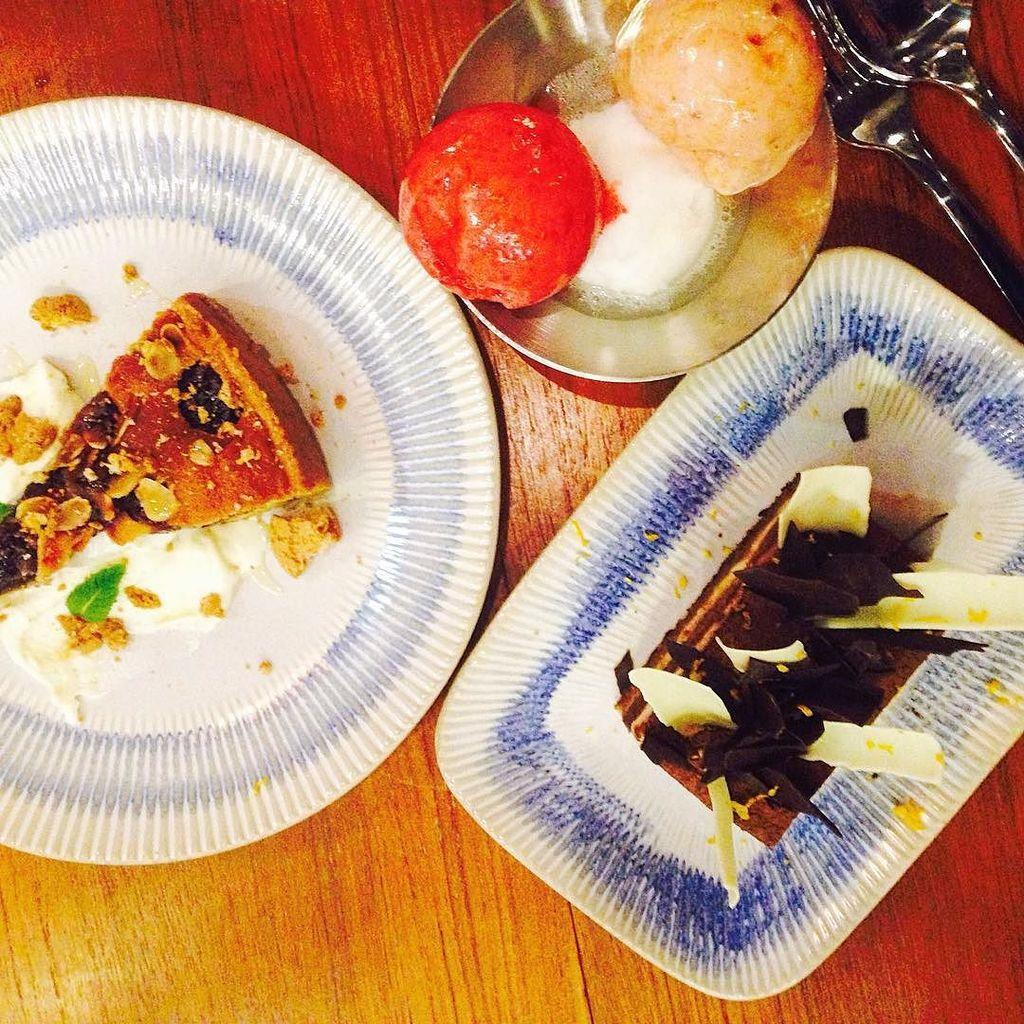What is located at the bottom of the image? There is a table at the bottom of the image. What is placed on the table? There are plates on the table. What is on the plates? The plates contain food. Where can utensils be found in the image? There is a fork and spoon in the top right side of the image. Is there any eggnog visible in the image? There is no mention of eggnog in the provided facts, so it cannot be determined if it is present in the image. 